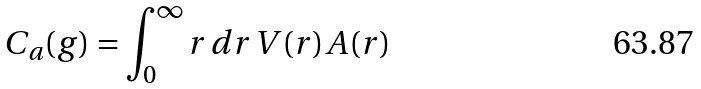Convert formula to latex. <formula><loc_0><loc_0><loc_500><loc_500>C _ { a } ( g ) = \int _ { 0 } ^ { \infty } r \, d r \, V ( r ) A ( r )</formula> 